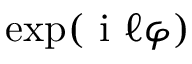Convert formula to latex. <formula><loc_0><loc_0><loc_500><loc_500>\exp ( i \ell \varphi )</formula> 